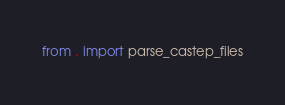<code> <loc_0><loc_0><loc_500><loc_500><_Python_>from . import parse_castep_files
</code> 